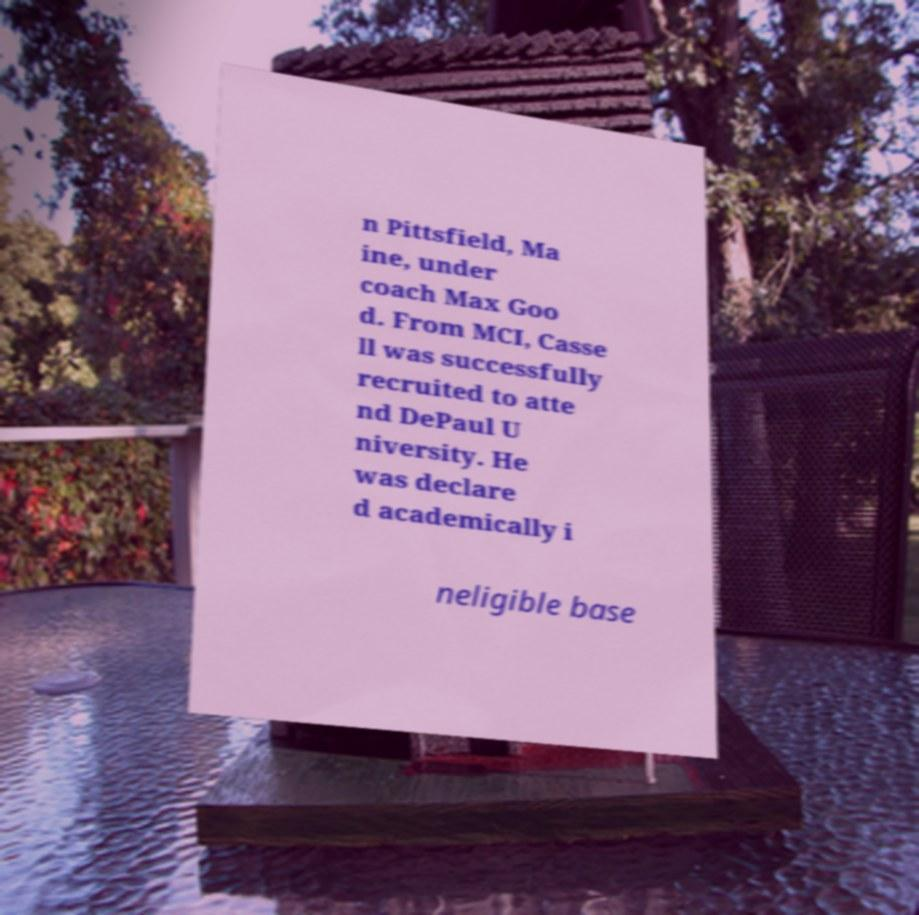Could you extract and type out the text from this image? n Pittsfield, Ma ine, under coach Max Goo d. From MCI, Casse ll was successfully recruited to atte nd DePaul U niversity. He was declare d academically i neligible base 